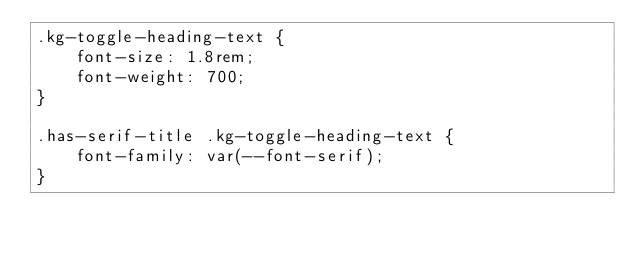<code> <loc_0><loc_0><loc_500><loc_500><_CSS_>.kg-toggle-heading-text {
    font-size: 1.8rem;
    font-weight: 700;
}

.has-serif-title .kg-toggle-heading-text {
    font-family: var(--font-serif);
}
</code> 